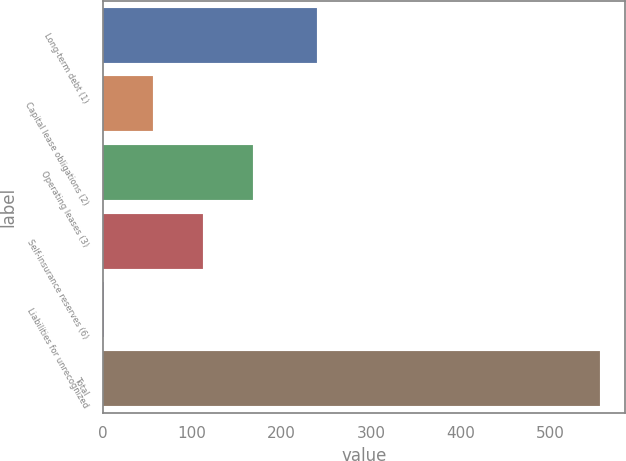<chart> <loc_0><loc_0><loc_500><loc_500><bar_chart><fcel>Long-term debt (1)<fcel>Capital lease obligations (2)<fcel>Operating leases (3)<fcel>Self-insurance reserves (6)<fcel>Liabilities for unrecognized<fcel>Total<nl><fcel>239.2<fcel>56.5<fcel>167.5<fcel>112<fcel>1<fcel>556<nl></chart> 